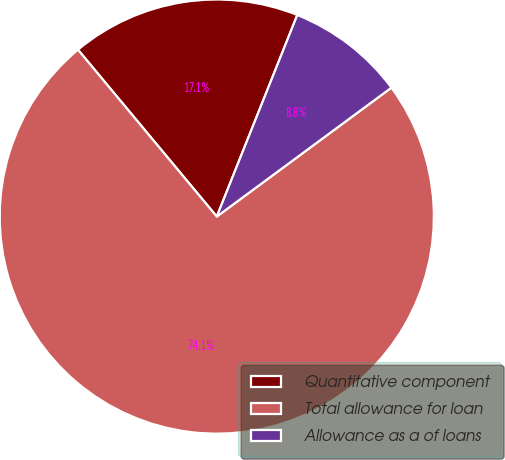Convert chart to OTSL. <chart><loc_0><loc_0><loc_500><loc_500><pie_chart><fcel>Quantitative component<fcel>Total allowance for loan<fcel>Allowance as a of loans<nl><fcel>17.09%<fcel>74.07%<fcel>8.83%<nl></chart> 